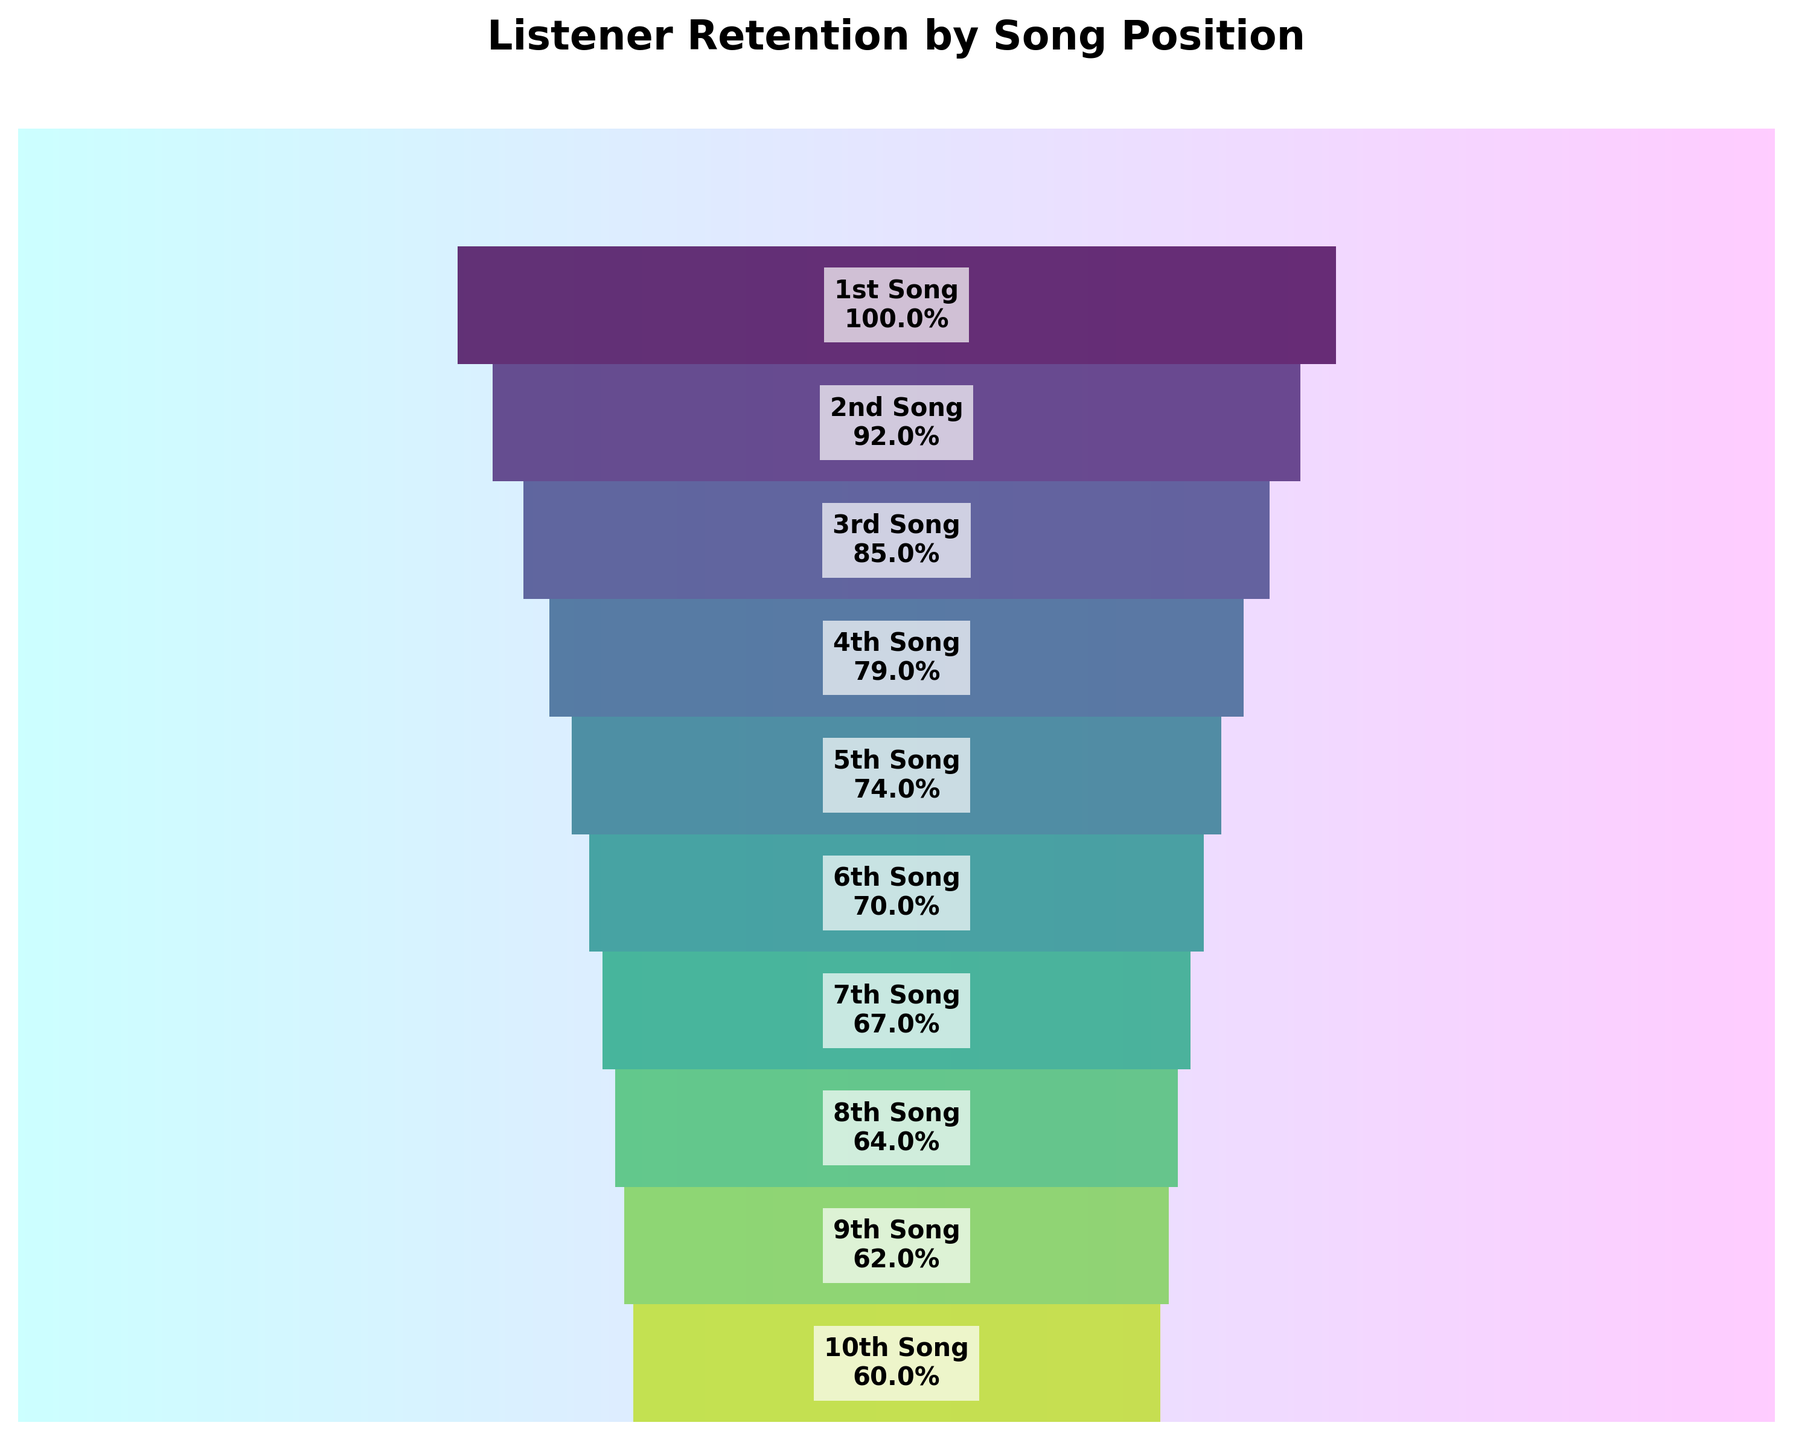What is the title of the figure? The title is usually found at the top of the figure. In this case, the title is "Listener Retention by Song Position".
Answer: Listener Retention by Song Position How many segments are there in the funnel chart? Each position in the playlist corresponds to one segment of the funnel. Counting each position gives us the total number of segments.
Answer: 10 What is the retention rate for the 5th song? Locate the segment labeled "5th Song" and read the retention rate indicated on the segment.
Answer: 74% What is the drop in retention rate from the 1st song to the 2nd song? Subtract the retention rate of the 2nd song (92%) from the 1st song (100%).
Answer: 8% What is the lowest retention rate on the chart? Identify the segment with the smallest retention rate value. In this chart, the lowest rate is at the 10th song.
Answer: 60% What is the average retention rate for the 1st three songs? Add the retention rates of the 1st (100%), 2nd (92%), and 3rd (85%) songs, then divide by 3 to find the average. (100 + 92 + 85) / 3 = 92.33
Answer: 92.33% What is the difference in retention rates from the 6th to the 10th song? Subtract the retention rate of the 10th song (60%) from the 6th song (70%).
Answer: 10% Which song positions have a retention rate below 70%? Identify all segments with retention rates less than 70%. These are the positions from the 7th to the 10th songs.
Answer: 7th, 8th, 9th, 10th How does the retention change in percentage points from the start to the end of the playlist? Subtract the retention rate at the last position (60%) from the rate at the first position (100%).
Answer: 40% What is the median retention rate of the given data? List all retention rates in numerical order: 60%, 62%, 64%, 67%, 70%, 74%, 79%, 85%, 92%, 100%. The median is the value in the middle; in this case, it is the average of the 5th and 6th values: (70% + 74%) / 2 = 72%.
Answer: 72% 